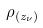<formula> <loc_0><loc_0><loc_500><loc_500>\rho _ { ( z _ { \nu } ) }</formula> 